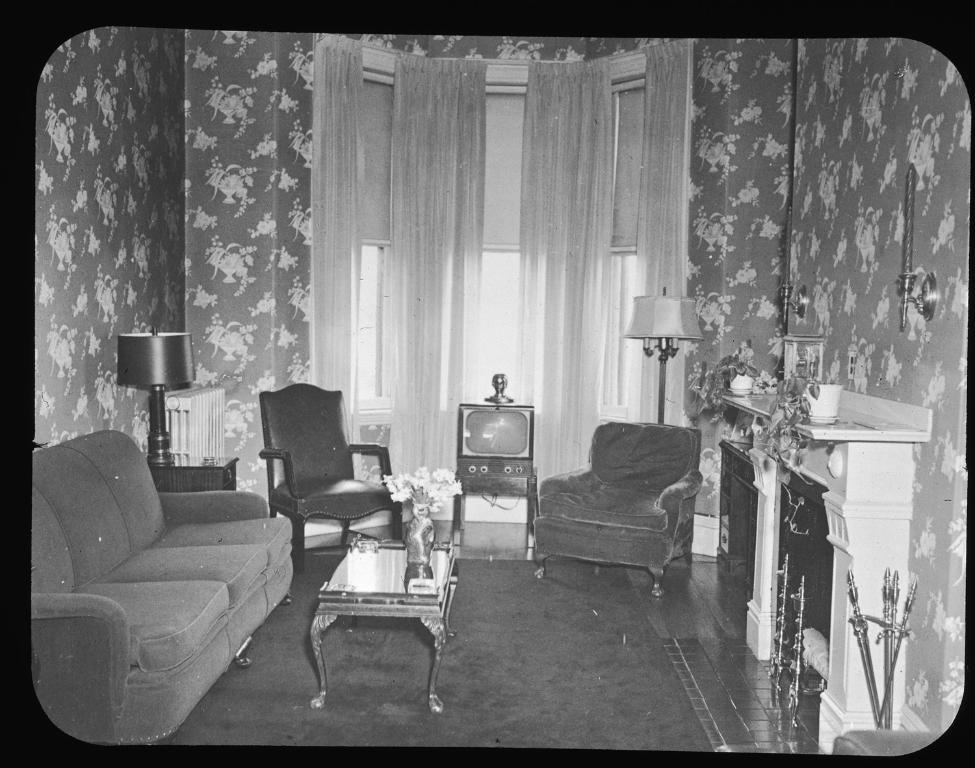What type of furniture is present in the image? There is a sofa and a chair in the image. What lighting fixture is visible in the image? There is a lamp in the image. What can be seen near the window in the image? There is a curtain near the window in the image. What type of electronic device is present in the image? There is a TV in the image. What decorative item is on a table in the image? There is a flower vase on a table in the image. What additional furniture piece is present in the image? There is a candle stand in the image. What color are the eyes of the person sitting on the sofa in the image? There are no people visible in the image, so it is not possible to determine the color of anyone's eyes. 